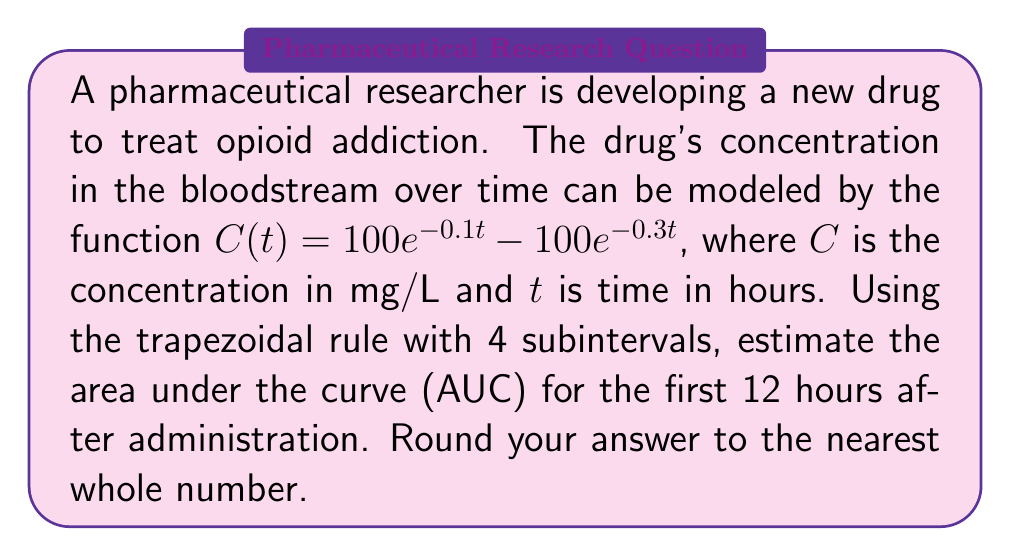Can you solve this math problem? To solve this problem, we'll use the trapezoidal rule with 4 subintervals to approximate the area under the curve (AUC) of the given function.

1) The trapezoidal rule formula for n subintervals is:

   $$\int_{a}^{b} f(x) dx \approx \frac{h}{2}[f(x_0) + 2f(x_1) + 2f(x_2) + ... + 2f(x_{n-1}) + f(x_n)]$$

   where $h = \frac{b-a}{n}$, and $x_i = a + ih$ for $i = 0, 1, ..., n$

2) In our case:
   $a = 0$, $b = 12$, $n = 4$
   $h = \frac{12-0}{4} = 3$

3) We need to calculate $C(t)$ at $t = 0, 3, 6, 9, 12$:

   $C(0) = 100e^{-0.1(0)} - 100e^{-0.3(0)} = 100 - 100 = 0$
   $C(3) = 100e^{-0.1(3)} - 100e^{-0.3(3)} = 74.08 - 40.66 = 33.42$
   $C(6) = 100e^{-0.1(6)} - 100e^{-0.3(6)} = 54.88 - 16.53 = 38.35$
   $C(9) = 100e^{-0.1(9)} - 100e^{-0.3(9)} = 40.66 - 6.72 = 33.94$
   $C(12) = 100e^{-0.1(12)} - 100e^{-0.3(12)} = 30.12 - 2.73 = 27.39$

4) Applying the trapezoidal rule:

   $$AUC \approx \frac{3}{2}[0 + 2(33.42) + 2(38.35) + 2(33.94) + 27.39]$$
   $$= \frac{3}{2}[0 + 66.84 + 76.70 + 67.88 + 27.39]$$
   $$= \frac{3}{2}(238.81)$$
   $$= 358.215$$

5) Rounding to the nearest whole number: 358
Answer: 358 mg·h/L 